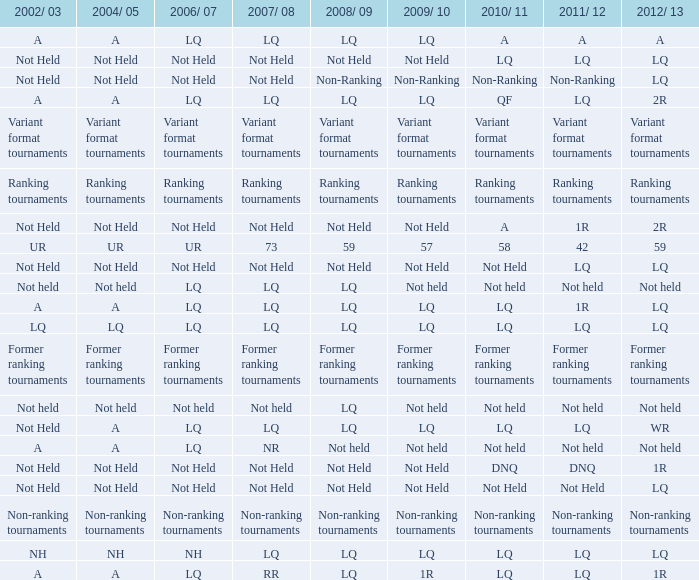Name the 2008/09 with 2004/05 of ranking tournaments Ranking tournaments. 